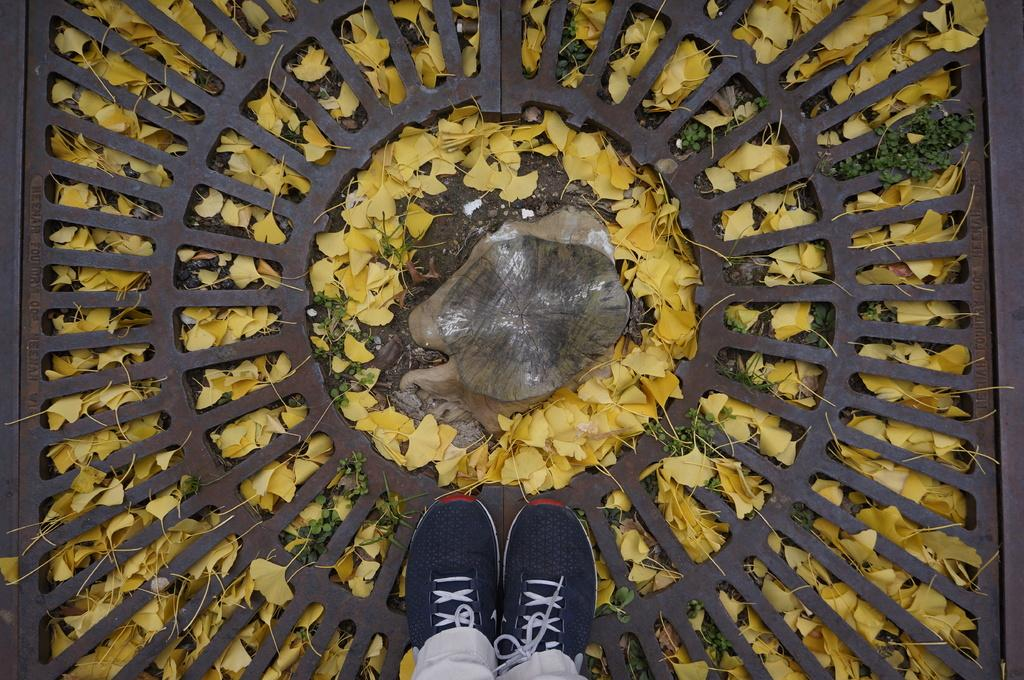What body part can be seen in the image? There are person's legs in the image. What type of material is visible in the image? There is a mesh in the image. What type of vegetation is present in the image? Leaves are present in the image. What part of a tree can be seen in the image? There is a tree trunk in the image. What type of washing system is present in the image? There is no washing system present in the image. How does the mesh stretch in the image? The mesh does not stretch in the image; it is stationary. 